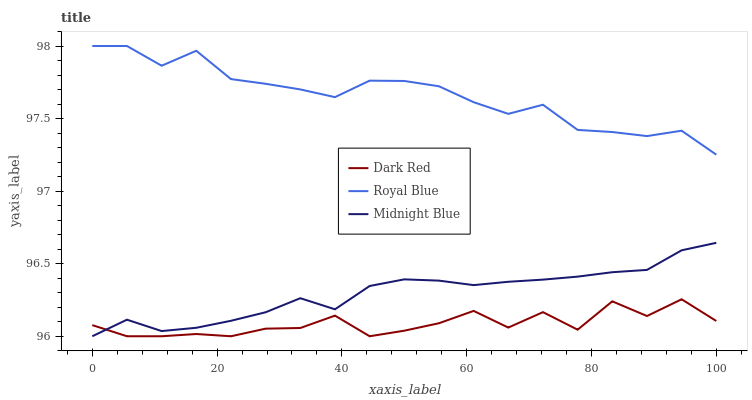Does Midnight Blue have the minimum area under the curve?
Answer yes or no. No. Does Midnight Blue have the maximum area under the curve?
Answer yes or no. No. Is Royal Blue the smoothest?
Answer yes or no. No. Is Royal Blue the roughest?
Answer yes or no. No. Does Royal Blue have the lowest value?
Answer yes or no. No. Does Midnight Blue have the highest value?
Answer yes or no. No. Is Dark Red less than Royal Blue?
Answer yes or no. Yes. Is Royal Blue greater than Midnight Blue?
Answer yes or no. Yes. Does Dark Red intersect Royal Blue?
Answer yes or no. No. 